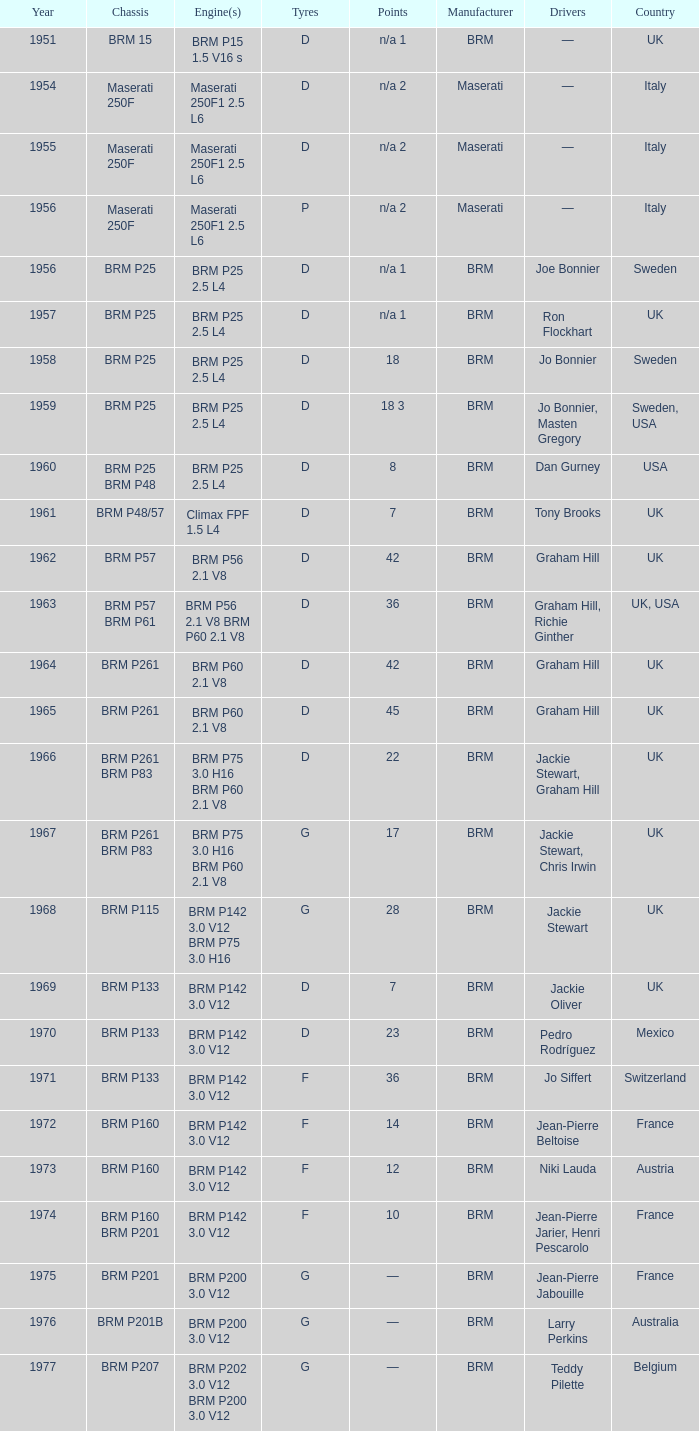Name the chassis for 1970 and tyres of d BRM P133. 